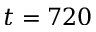<formula> <loc_0><loc_0><loc_500><loc_500>t = 7 2 0</formula> 